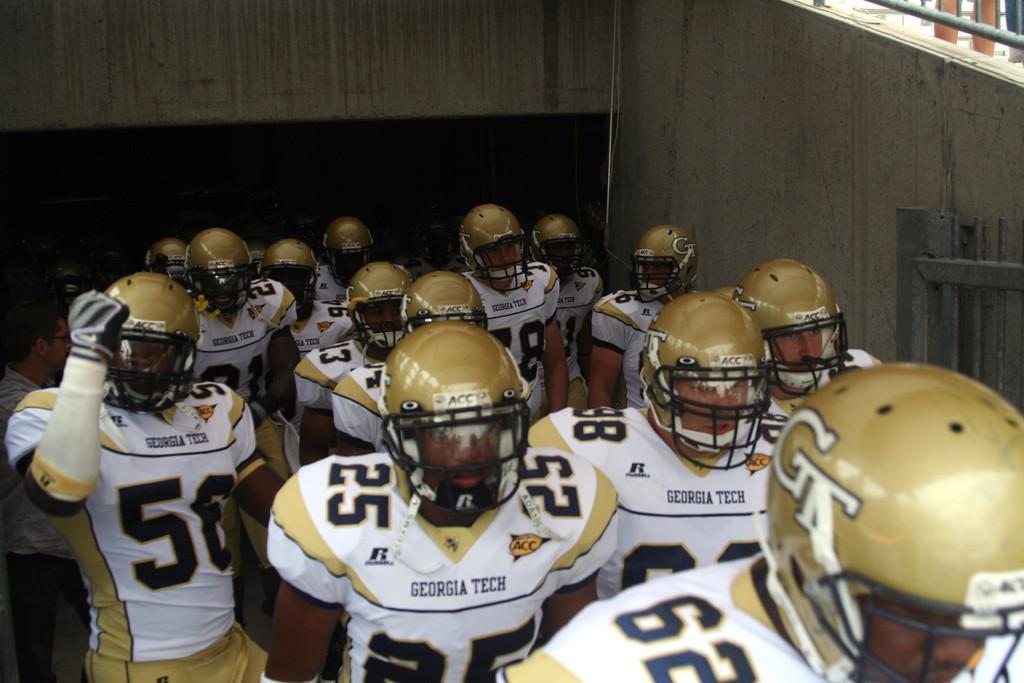What is the main subject of the image? The main subject of the image is a group of people. What are the people wearing in the image? The people are wearing white and gold color dresses and helmets. What can be seen in the background of the image? There is a wall visible in the background of the image. Can you tell me how many snails are crawling on the helmets in the image? There are no snails present in the image; the people are wearing helmets, but there are no snails visible. What type of authority figure is depicted in the image? The image does not depict any specific authority figure; it simply shows a group of people wearing helmets and white and gold color dresses. 